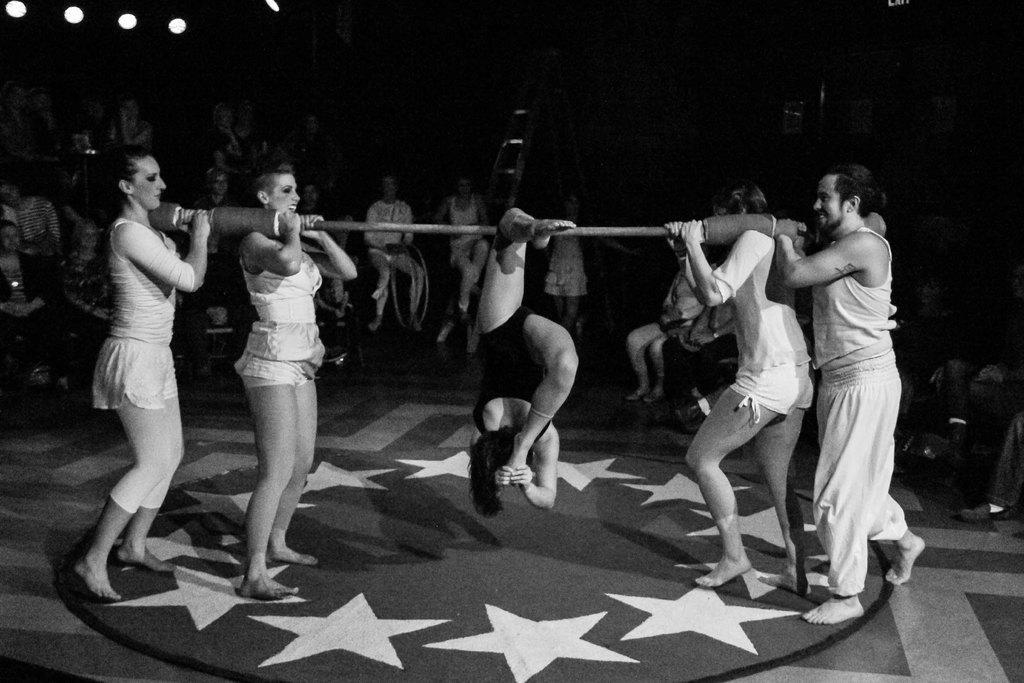Describe this image in one or two sentences. This image is a black and white image. This image is taken indoors. At the bottom of the image there is a floor with a mat. In the background a few people are sitting on the chairs. In this image the background is dark and there are a few lights. In the middle of the image a woman is doing gymnastics with a stick and four people are holding a stick in their hands. 